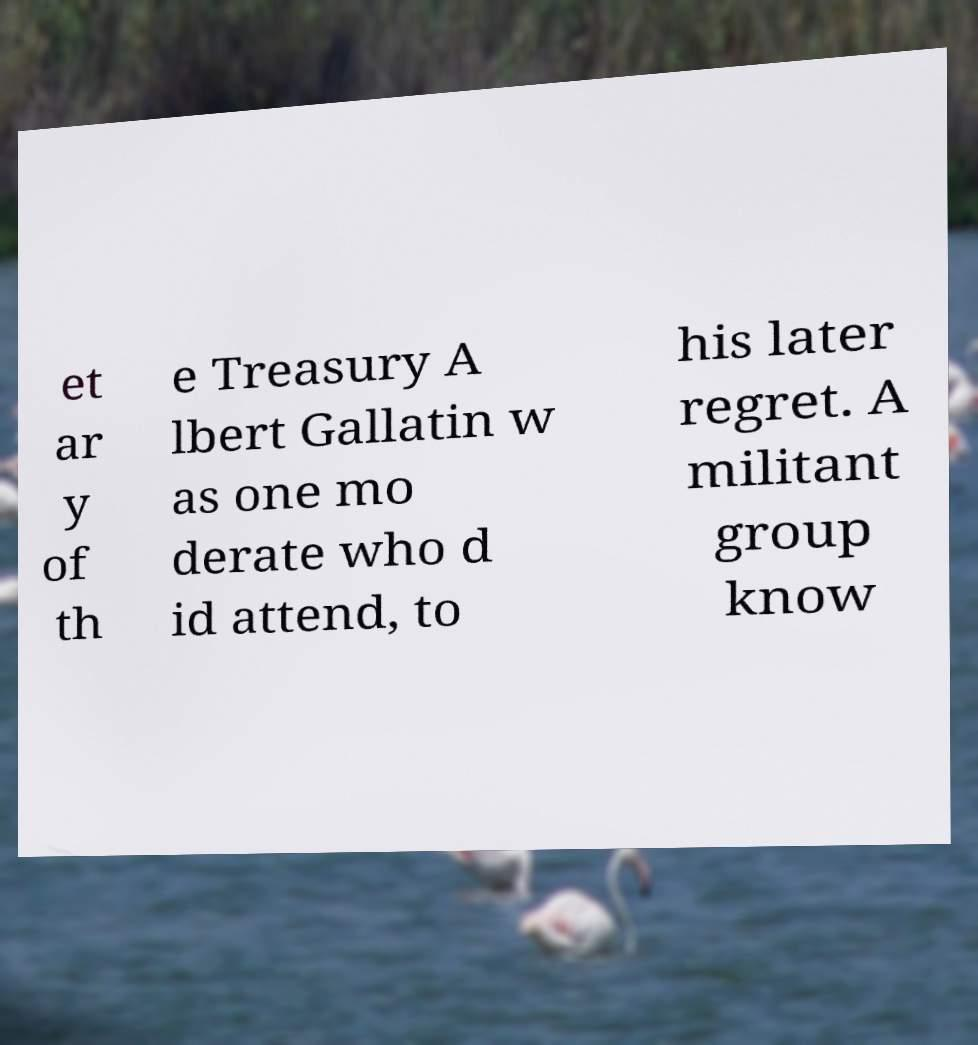Please read and relay the text visible in this image. What does it say? et ar y of th e Treasury A lbert Gallatin w as one mo derate who d id attend, to his later regret. A militant group know 